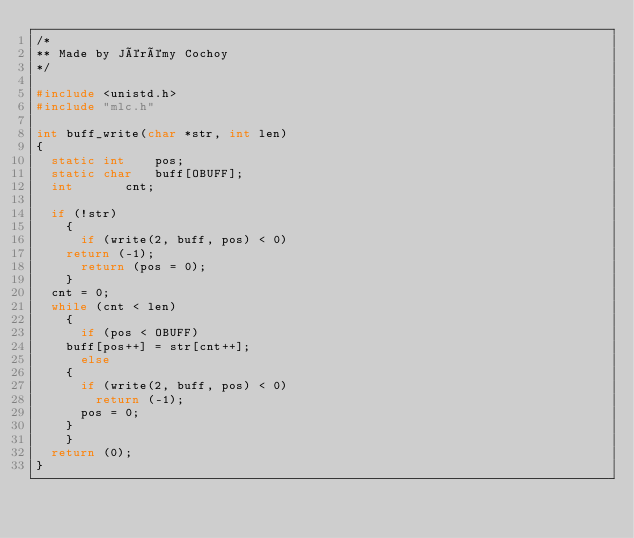<code> <loc_0><loc_0><loc_500><loc_500><_C_>/*
** Made by Jérémy Cochoy
*/

#include <unistd.h>
#include "mlc.h"

int	buff_write(char *str, int len)
{
  static int	pos;
  static char	buff[OBUFF];
  int		cnt;

  if (!str)
    {
      if (write(2, buff, pos) < 0)
	return (-1);
      return (pos = 0);
    }
  cnt = 0;
  while (cnt < len)
    {
      if (pos < OBUFF)
	buff[pos++] = str[cnt++];
      else
	{
	  if (write(2, buff, pos) < 0)
	    return (-1);
	  pos = 0;
	}
    }
  return (0);
}
</code> 